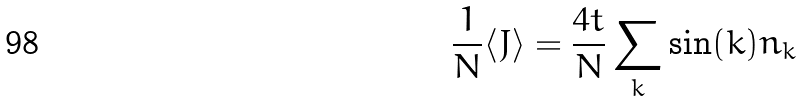<formula> <loc_0><loc_0><loc_500><loc_500>\frac { 1 } { N } \langle J \rangle = \frac { 4 t } { N } \sum _ { k } \sin ( k ) n _ { k }</formula> 